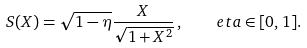Convert formula to latex. <formula><loc_0><loc_0><loc_500><loc_500>S ( X ) = \sqrt { 1 - \eta } \frac { X } { \sqrt { 1 + X ^ { 2 } } } \, , \quad e t a \in [ 0 , 1 ] .</formula> 